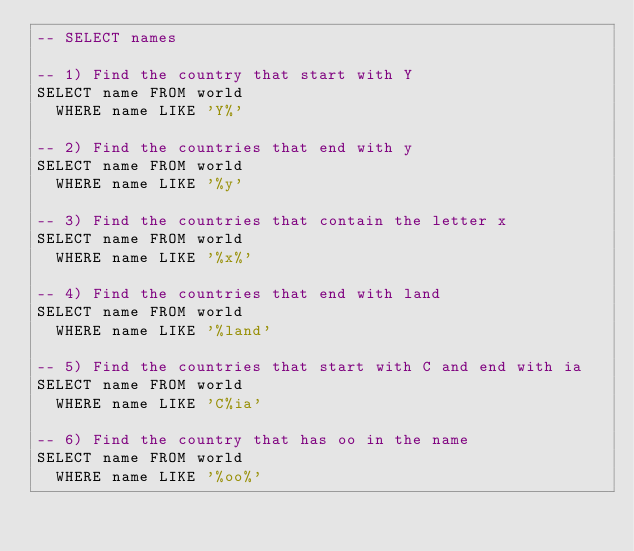<code> <loc_0><loc_0><loc_500><loc_500><_SQL_>-- SELECT names

-- 1) Find the country that start with Y
SELECT name FROM world
  WHERE name LIKE 'Y%'
  
-- 2) Find the countries that end with y
SELECT name FROM world
  WHERE name LIKE '%y'

-- 3) Find the countries that contain the letter x
SELECT name FROM world
  WHERE name LIKE '%x%'

-- 4) Find the countries that end with land
SELECT name FROM world
  WHERE name LIKE '%land'

-- 5) Find the countries that start with C and end with ia
SELECT name FROM world
  WHERE name LIKE 'C%ia'

-- 6) Find the country that has oo in the name
SELECT name FROM world
  WHERE name LIKE '%oo%'
</code> 